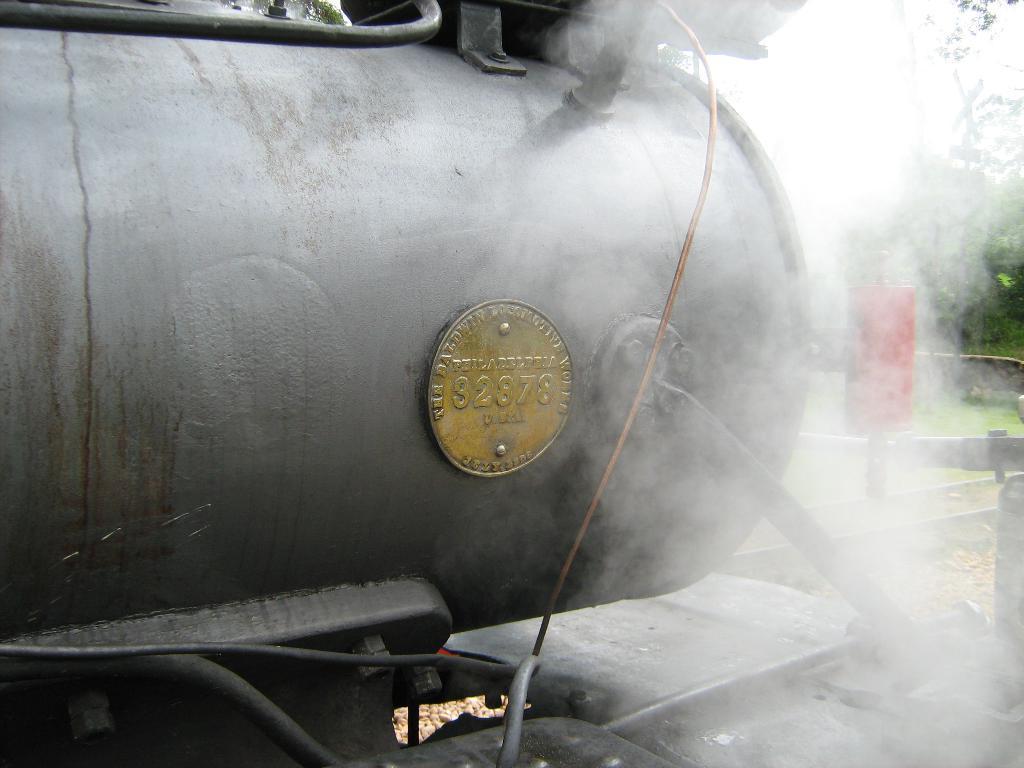In one or two sentences, can you explain what this image depicts? In this image I can see a black colour engine and on it I can see a golden colour plate. On the plate I can see something is written. On the right side of this image I can see a red colour thing and few trees. I can also see smoke on the right side. 